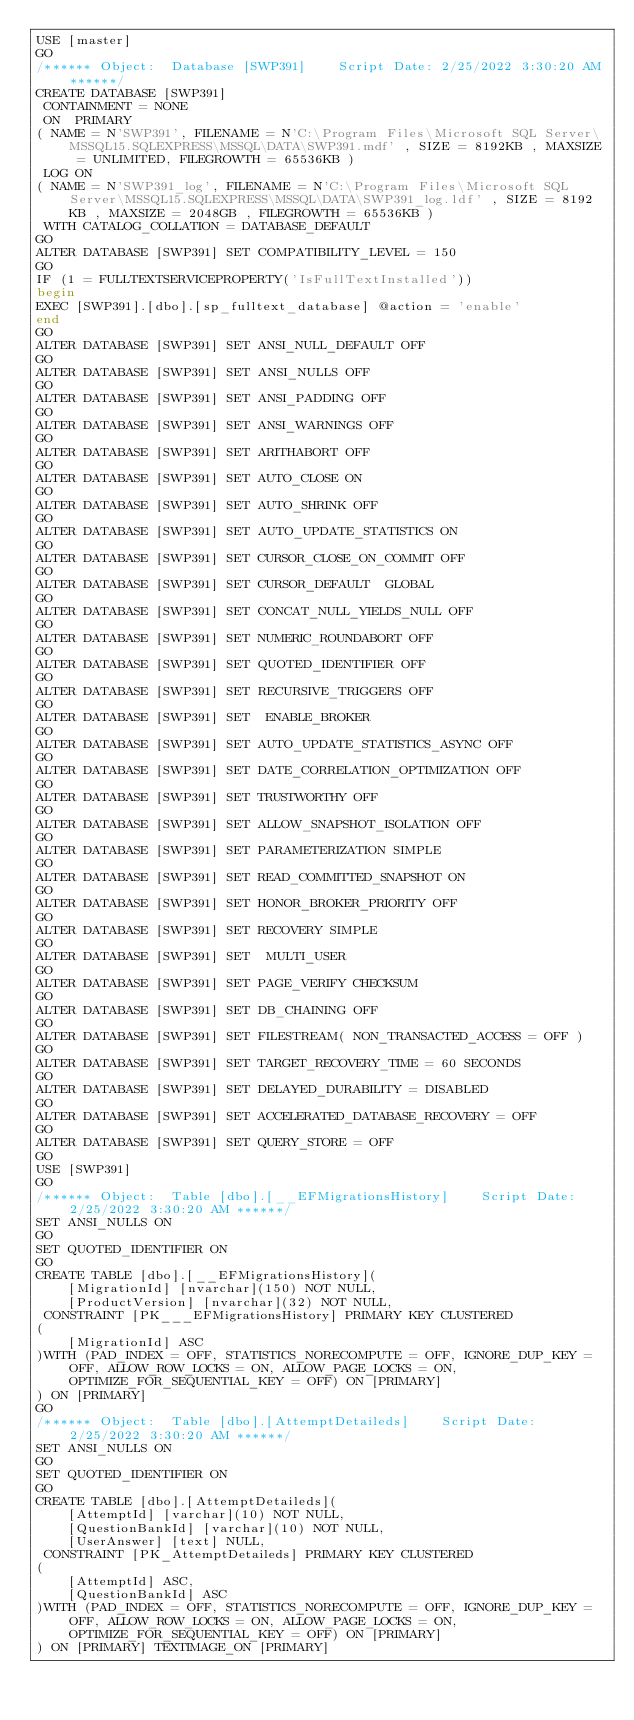<code> <loc_0><loc_0><loc_500><loc_500><_SQL_>USE [master]
GO
/****** Object:  Database [SWP391]    Script Date: 2/25/2022 3:30:20 AM ******/
CREATE DATABASE [SWP391]
 CONTAINMENT = NONE
 ON  PRIMARY 
( NAME = N'SWP391', FILENAME = N'C:\Program Files\Microsoft SQL Server\MSSQL15.SQLEXPRESS\MSSQL\DATA\SWP391.mdf' , SIZE = 8192KB , MAXSIZE = UNLIMITED, FILEGROWTH = 65536KB )
 LOG ON 
( NAME = N'SWP391_log', FILENAME = N'C:\Program Files\Microsoft SQL Server\MSSQL15.SQLEXPRESS\MSSQL\DATA\SWP391_log.ldf' , SIZE = 8192KB , MAXSIZE = 2048GB , FILEGROWTH = 65536KB )
 WITH CATALOG_COLLATION = DATABASE_DEFAULT
GO
ALTER DATABASE [SWP391] SET COMPATIBILITY_LEVEL = 150
GO
IF (1 = FULLTEXTSERVICEPROPERTY('IsFullTextInstalled'))
begin
EXEC [SWP391].[dbo].[sp_fulltext_database] @action = 'enable'
end
GO
ALTER DATABASE [SWP391] SET ANSI_NULL_DEFAULT OFF 
GO
ALTER DATABASE [SWP391] SET ANSI_NULLS OFF 
GO
ALTER DATABASE [SWP391] SET ANSI_PADDING OFF 
GO
ALTER DATABASE [SWP391] SET ANSI_WARNINGS OFF 
GO
ALTER DATABASE [SWP391] SET ARITHABORT OFF 
GO
ALTER DATABASE [SWP391] SET AUTO_CLOSE ON 
GO
ALTER DATABASE [SWP391] SET AUTO_SHRINK OFF 
GO
ALTER DATABASE [SWP391] SET AUTO_UPDATE_STATISTICS ON 
GO
ALTER DATABASE [SWP391] SET CURSOR_CLOSE_ON_COMMIT OFF 
GO
ALTER DATABASE [SWP391] SET CURSOR_DEFAULT  GLOBAL 
GO
ALTER DATABASE [SWP391] SET CONCAT_NULL_YIELDS_NULL OFF 
GO
ALTER DATABASE [SWP391] SET NUMERIC_ROUNDABORT OFF 
GO
ALTER DATABASE [SWP391] SET QUOTED_IDENTIFIER OFF 
GO
ALTER DATABASE [SWP391] SET RECURSIVE_TRIGGERS OFF 
GO
ALTER DATABASE [SWP391] SET  ENABLE_BROKER 
GO
ALTER DATABASE [SWP391] SET AUTO_UPDATE_STATISTICS_ASYNC OFF 
GO
ALTER DATABASE [SWP391] SET DATE_CORRELATION_OPTIMIZATION OFF 
GO
ALTER DATABASE [SWP391] SET TRUSTWORTHY OFF 
GO
ALTER DATABASE [SWP391] SET ALLOW_SNAPSHOT_ISOLATION OFF 
GO
ALTER DATABASE [SWP391] SET PARAMETERIZATION SIMPLE 
GO
ALTER DATABASE [SWP391] SET READ_COMMITTED_SNAPSHOT ON 
GO
ALTER DATABASE [SWP391] SET HONOR_BROKER_PRIORITY OFF 
GO
ALTER DATABASE [SWP391] SET RECOVERY SIMPLE 
GO
ALTER DATABASE [SWP391] SET  MULTI_USER 
GO
ALTER DATABASE [SWP391] SET PAGE_VERIFY CHECKSUM  
GO
ALTER DATABASE [SWP391] SET DB_CHAINING OFF 
GO
ALTER DATABASE [SWP391] SET FILESTREAM( NON_TRANSACTED_ACCESS = OFF ) 
GO
ALTER DATABASE [SWP391] SET TARGET_RECOVERY_TIME = 60 SECONDS 
GO
ALTER DATABASE [SWP391] SET DELAYED_DURABILITY = DISABLED 
GO
ALTER DATABASE [SWP391] SET ACCELERATED_DATABASE_RECOVERY = OFF  
GO
ALTER DATABASE [SWP391] SET QUERY_STORE = OFF
GO
USE [SWP391]
GO
/****** Object:  Table [dbo].[__EFMigrationsHistory]    Script Date: 2/25/2022 3:30:20 AM ******/
SET ANSI_NULLS ON
GO
SET QUOTED_IDENTIFIER ON
GO
CREATE TABLE [dbo].[__EFMigrationsHistory](
	[MigrationId] [nvarchar](150) NOT NULL,
	[ProductVersion] [nvarchar](32) NOT NULL,
 CONSTRAINT [PK___EFMigrationsHistory] PRIMARY KEY CLUSTERED 
(
	[MigrationId] ASC
)WITH (PAD_INDEX = OFF, STATISTICS_NORECOMPUTE = OFF, IGNORE_DUP_KEY = OFF, ALLOW_ROW_LOCKS = ON, ALLOW_PAGE_LOCKS = ON, OPTIMIZE_FOR_SEQUENTIAL_KEY = OFF) ON [PRIMARY]
) ON [PRIMARY]
GO
/****** Object:  Table [dbo].[AttemptDetaileds]    Script Date: 2/25/2022 3:30:20 AM ******/
SET ANSI_NULLS ON
GO
SET QUOTED_IDENTIFIER ON
GO
CREATE TABLE [dbo].[AttemptDetaileds](
	[AttemptId] [varchar](10) NOT NULL,
	[QuestionBankId] [varchar](10) NOT NULL,
	[UserAnswer] [text] NULL,
 CONSTRAINT [PK_AttemptDetaileds] PRIMARY KEY CLUSTERED 
(
	[AttemptId] ASC,
	[QuestionBankId] ASC
)WITH (PAD_INDEX = OFF, STATISTICS_NORECOMPUTE = OFF, IGNORE_DUP_KEY = OFF, ALLOW_ROW_LOCKS = ON, ALLOW_PAGE_LOCKS = ON, OPTIMIZE_FOR_SEQUENTIAL_KEY = OFF) ON [PRIMARY]
) ON [PRIMARY] TEXTIMAGE_ON [PRIMARY]</code> 